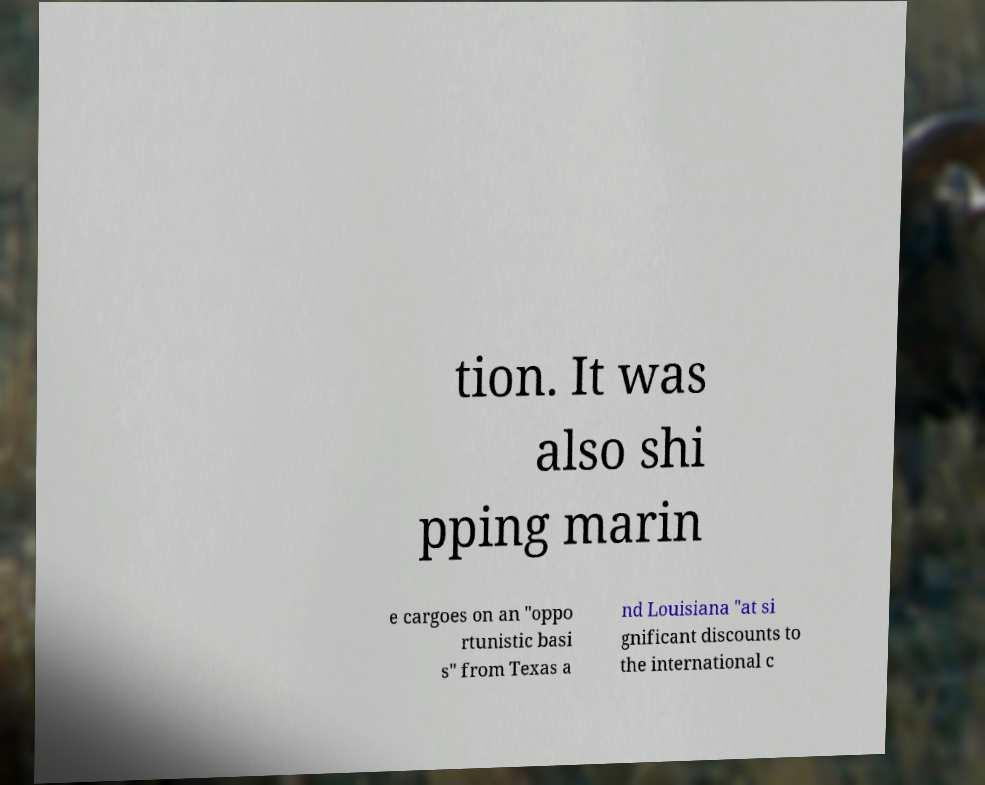For documentation purposes, I need the text within this image transcribed. Could you provide that? tion. It was also shi pping marin e cargoes on an "oppo rtunistic basi s" from Texas a nd Louisiana "at si gnificant discounts to the international c 